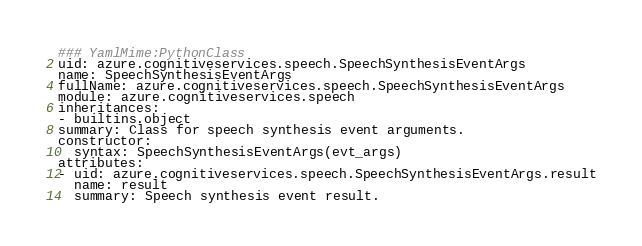Convert code to text. <code><loc_0><loc_0><loc_500><loc_500><_YAML_>### YamlMime:PythonClass
uid: azure.cognitiveservices.speech.SpeechSynthesisEventArgs
name: SpeechSynthesisEventArgs
fullName: azure.cognitiveservices.speech.SpeechSynthesisEventArgs
module: azure.cognitiveservices.speech
inheritances:
- builtins.object
summary: Class for speech synthesis event arguments.
constructor:
  syntax: SpeechSynthesisEventArgs(evt_args)
attributes:
- uid: azure.cognitiveservices.speech.SpeechSynthesisEventArgs.result
  name: result
  summary: Speech synthesis event result.
</code> 